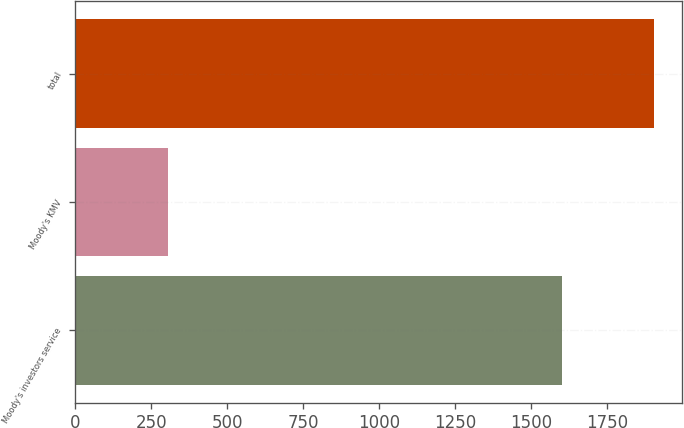Convert chart to OTSL. <chart><loc_0><loc_0><loc_500><loc_500><bar_chart><fcel>Moody's investors service<fcel>Moody's KMV<fcel>total<nl><fcel>1600<fcel>303<fcel>1903<nl></chart> 